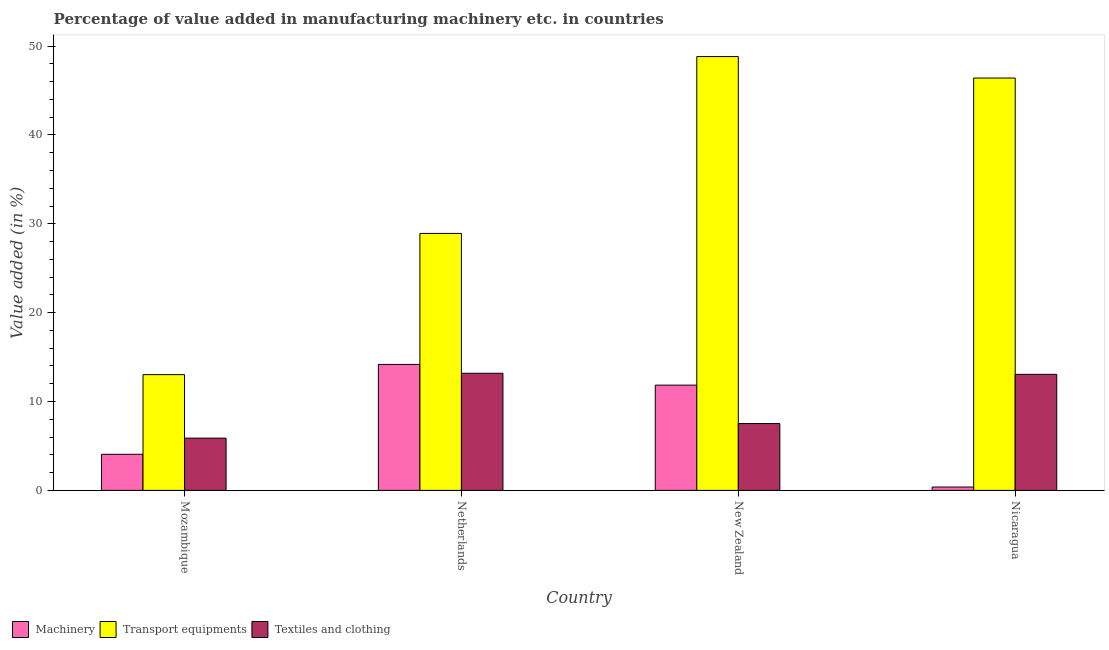Are the number of bars per tick equal to the number of legend labels?
Offer a terse response. Yes. What is the value added in manufacturing transport equipments in New Zealand?
Give a very brief answer. 48.82. Across all countries, what is the maximum value added in manufacturing machinery?
Your answer should be compact. 14.18. Across all countries, what is the minimum value added in manufacturing machinery?
Your response must be concise. 0.38. In which country was the value added in manufacturing textile and clothing minimum?
Keep it short and to the point. Mozambique. What is the total value added in manufacturing machinery in the graph?
Give a very brief answer. 30.46. What is the difference between the value added in manufacturing textile and clothing in Netherlands and that in Nicaragua?
Your answer should be very brief. 0.12. What is the difference between the value added in manufacturing textile and clothing in Nicaragua and the value added in manufacturing transport equipments in Mozambique?
Provide a short and direct response. 0.03. What is the average value added in manufacturing transport equipments per country?
Give a very brief answer. 34.29. What is the difference between the value added in manufacturing textile and clothing and value added in manufacturing machinery in Mozambique?
Provide a succinct answer. 1.82. What is the ratio of the value added in manufacturing transport equipments in Netherlands to that in New Zealand?
Provide a succinct answer. 0.59. Is the value added in manufacturing machinery in Netherlands less than that in New Zealand?
Give a very brief answer. No. What is the difference between the highest and the second highest value added in manufacturing machinery?
Offer a terse response. 2.33. What is the difference between the highest and the lowest value added in manufacturing machinery?
Make the answer very short. 13.8. Is the sum of the value added in manufacturing textile and clothing in Mozambique and Netherlands greater than the maximum value added in manufacturing machinery across all countries?
Provide a succinct answer. Yes. What does the 1st bar from the left in New Zealand represents?
Provide a succinct answer. Machinery. What does the 1st bar from the right in Netherlands represents?
Your answer should be compact. Textiles and clothing. How many bars are there?
Your answer should be very brief. 12. Are all the bars in the graph horizontal?
Your answer should be compact. No. How many countries are there in the graph?
Provide a succinct answer. 4. What is the difference between two consecutive major ticks on the Y-axis?
Offer a very short reply. 10. Are the values on the major ticks of Y-axis written in scientific E-notation?
Your response must be concise. No. Does the graph contain any zero values?
Provide a succinct answer. No. Does the graph contain grids?
Give a very brief answer. No. Where does the legend appear in the graph?
Provide a succinct answer. Bottom left. How many legend labels are there?
Offer a very short reply. 3. What is the title of the graph?
Provide a succinct answer. Percentage of value added in manufacturing machinery etc. in countries. Does "Renewable sources" appear as one of the legend labels in the graph?
Offer a very short reply. No. What is the label or title of the X-axis?
Ensure brevity in your answer.  Country. What is the label or title of the Y-axis?
Provide a succinct answer. Value added (in %). What is the Value added (in %) of Machinery in Mozambique?
Your answer should be compact. 4.06. What is the Value added (in %) of Transport equipments in Mozambique?
Provide a short and direct response. 13.03. What is the Value added (in %) of Textiles and clothing in Mozambique?
Your answer should be very brief. 5.88. What is the Value added (in %) of Machinery in Netherlands?
Your answer should be very brief. 14.18. What is the Value added (in %) in Transport equipments in Netherlands?
Your response must be concise. 28.92. What is the Value added (in %) of Textiles and clothing in Netherlands?
Make the answer very short. 13.18. What is the Value added (in %) in Machinery in New Zealand?
Your answer should be very brief. 11.84. What is the Value added (in %) of Transport equipments in New Zealand?
Make the answer very short. 48.82. What is the Value added (in %) in Textiles and clothing in New Zealand?
Give a very brief answer. 7.52. What is the Value added (in %) in Machinery in Nicaragua?
Your answer should be very brief. 0.38. What is the Value added (in %) of Transport equipments in Nicaragua?
Offer a very short reply. 46.4. What is the Value added (in %) in Textiles and clothing in Nicaragua?
Your answer should be compact. 13.06. Across all countries, what is the maximum Value added (in %) in Machinery?
Make the answer very short. 14.18. Across all countries, what is the maximum Value added (in %) of Transport equipments?
Keep it short and to the point. 48.82. Across all countries, what is the maximum Value added (in %) of Textiles and clothing?
Give a very brief answer. 13.18. Across all countries, what is the minimum Value added (in %) of Machinery?
Ensure brevity in your answer.  0.38. Across all countries, what is the minimum Value added (in %) in Transport equipments?
Give a very brief answer. 13.03. Across all countries, what is the minimum Value added (in %) in Textiles and clothing?
Offer a very short reply. 5.88. What is the total Value added (in %) in Machinery in the graph?
Offer a terse response. 30.46. What is the total Value added (in %) of Transport equipments in the graph?
Offer a very short reply. 137.17. What is the total Value added (in %) in Textiles and clothing in the graph?
Keep it short and to the point. 39.64. What is the difference between the Value added (in %) in Machinery in Mozambique and that in Netherlands?
Keep it short and to the point. -10.11. What is the difference between the Value added (in %) of Transport equipments in Mozambique and that in Netherlands?
Provide a short and direct response. -15.89. What is the difference between the Value added (in %) of Textiles and clothing in Mozambique and that in Netherlands?
Your response must be concise. -7.3. What is the difference between the Value added (in %) of Machinery in Mozambique and that in New Zealand?
Give a very brief answer. -7.78. What is the difference between the Value added (in %) in Transport equipments in Mozambique and that in New Zealand?
Offer a terse response. -35.79. What is the difference between the Value added (in %) of Textiles and clothing in Mozambique and that in New Zealand?
Ensure brevity in your answer.  -1.64. What is the difference between the Value added (in %) in Machinery in Mozambique and that in Nicaragua?
Your answer should be compact. 3.68. What is the difference between the Value added (in %) of Transport equipments in Mozambique and that in Nicaragua?
Keep it short and to the point. -33.38. What is the difference between the Value added (in %) in Textiles and clothing in Mozambique and that in Nicaragua?
Provide a succinct answer. -7.18. What is the difference between the Value added (in %) of Machinery in Netherlands and that in New Zealand?
Ensure brevity in your answer.  2.33. What is the difference between the Value added (in %) of Transport equipments in Netherlands and that in New Zealand?
Offer a terse response. -19.9. What is the difference between the Value added (in %) in Textiles and clothing in Netherlands and that in New Zealand?
Keep it short and to the point. 5.66. What is the difference between the Value added (in %) in Machinery in Netherlands and that in Nicaragua?
Offer a terse response. 13.8. What is the difference between the Value added (in %) in Transport equipments in Netherlands and that in Nicaragua?
Ensure brevity in your answer.  -17.49. What is the difference between the Value added (in %) in Textiles and clothing in Netherlands and that in Nicaragua?
Your answer should be very brief. 0.12. What is the difference between the Value added (in %) in Machinery in New Zealand and that in Nicaragua?
Give a very brief answer. 11.47. What is the difference between the Value added (in %) in Transport equipments in New Zealand and that in Nicaragua?
Your response must be concise. 2.41. What is the difference between the Value added (in %) in Textiles and clothing in New Zealand and that in Nicaragua?
Your answer should be compact. -5.54. What is the difference between the Value added (in %) in Machinery in Mozambique and the Value added (in %) in Transport equipments in Netherlands?
Give a very brief answer. -24.86. What is the difference between the Value added (in %) of Machinery in Mozambique and the Value added (in %) of Textiles and clothing in Netherlands?
Provide a succinct answer. -9.12. What is the difference between the Value added (in %) of Transport equipments in Mozambique and the Value added (in %) of Textiles and clothing in Netherlands?
Your response must be concise. -0.15. What is the difference between the Value added (in %) of Machinery in Mozambique and the Value added (in %) of Transport equipments in New Zealand?
Give a very brief answer. -44.76. What is the difference between the Value added (in %) of Machinery in Mozambique and the Value added (in %) of Textiles and clothing in New Zealand?
Keep it short and to the point. -3.46. What is the difference between the Value added (in %) in Transport equipments in Mozambique and the Value added (in %) in Textiles and clothing in New Zealand?
Give a very brief answer. 5.51. What is the difference between the Value added (in %) in Machinery in Mozambique and the Value added (in %) in Transport equipments in Nicaragua?
Ensure brevity in your answer.  -42.34. What is the difference between the Value added (in %) of Machinery in Mozambique and the Value added (in %) of Textiles and clothing in Nicaragua?
Give a very brief answer. -9. What is the difference between the Value added (in %) in Transport equipments in Mozambique and the Value added (in %) in Textiles and clothing in Nicaragua?
Provide a succinct answer. -0.03. What is the difference between the Value added (in %) of Machinery in Netherlands and the Value added (in %) of Transport equipments in New Zealand?
Offer a very short reply. -34.64. What is the difference between the Value added (in %) of Machinery in Netherlands and the Value added (in %) of Textiles and clothing in New Zealand?
Keep it short and to the point. 6.66. What is the difference between the Value added (in %) of Transport equipments in Netherlands and the Value added (in %) of Textiles and clothing in New Zealand?
Offer a terse response. 21.4. What is the difference between the Value added (in %) in Machinery in Netherlands and the Value added (in %) in Transport equipments in Nicaragua?
Make the answer very short. -32.23. What is the difference between the Value added (in %) of Machinery in Netherlands and the Value added (in %) of Textiles and clothing in Nicaragua?
Keep it short and to the point. 1.12. What is the difference between the Value added (in %) in Transport equipments in Netherlands and the Value added (in %) in Textiles and clothing in Nicaragua?
Offer a terse response. 15.86. What is the difference between the Value added (in %) in Machinery in New Zealand and the Value added (in %) in Transport equipments in Nicaragua?
Provide a succinct answer. -34.56. What is the difference between the Value added (in %) of Machinery in New Zealand and the Value added (in %) of Textiles and clothing in Nicaragua?
Give a very brief answer. -1.22. What is the difference between the Value added (in %) of Transport equipments in New Zealand and the Value added (in %) of Textiles and clothing in Nicaragua?
Offer a very short reply. 35.76. What is the average Value added (in %) in Machinery per country?
Provide a succinct answer. 7.62. What is the average Value added (in %) of Transport equipments per country?
Your answer should be very brief. 34.29. What is the average Value added (in %) of Textiles and clothing per country?
Your answer should be compact. 9.91. What is the difference between the Value added (in %) in Machinery and Value added (in %) in Transport equipments in Mozambique?
Offer a terse response. -8.97. What is the difference between the Value added (in %) of Machinery and Value added (in %) of Textiles and clothing in Mozambique?
Keep it short and to the point. -1.82. What is the difference between the Value added (in %) of Transport equipments and Value added (in %) of Textiles and clothing in Mozambique?
Your response must be concise. 7.14. What is the difference between the Value added (in %) in Machinery and Value added (in %) in Transport equipments in Netherlands?
Your response must be concise. -14.74. What is the difference between the Value added (in %) in Machinery and Value added (in %) in Textiles and clothing in Netherlands?
Your answer should be compact. 1. What is the difference between the Value added (in %) in Transport equipments and Value added (in %) in Textiles and clothing in Netherlands?
Make the answer very short. 15.74. What is the difference between the Value added (in %) of Machinery and Value added (in %) of Transport equipments in New Zealand?
Make the answer very short. -36.97. What is the difference between the Value added (in %) in Machinery and Value added (in %) in Textiles and clothing in New Zealand?
Ensure brevity in your answer.  4.32. What is the difference between the Value added (in %) in Transport equipments and Value added (in %) in Textiles and clothing in New Zealand?
Offer a very short reply. 41.3. What is the difference between the Value added (in %) in Machinery and Value added (in %) in Transport equipments in Nicaragua?
Offer a terse response. -46.03. What is the difference between the Value added (in %) in Machinery and Value added (in %) in Textiles and clothing in Nicaragua?
Make the answer very short. -12.68. What is the difference between the Value added (in %) of Transport equipments and Value added (in %) of Textiles and clothing in Nicaragua?
Give a very brief answer. 33.35. What is the ratio of the Value added (in %) of Machinery in Mozambique to that in Netherlands?
Your answer should be very brief. 0.29. What is the ratio of the Value added (in %) in Transport equipments in Mozambique to that in Netherlands?
Provide a short and direct response. 0.45. What is the ratio of the Value added (in %) of Textiles and clothing in Mozambique to that in Netherlands?
Offer a terse response. 0.45. What is the ratio of the Value added (in %) in Machinery in Mozambique to that in New Zealand?
Offer a terse response. 0.34. What is the ratio of the Value added (in %) of Transport equipments in Mozambique to that in New Zealand?
Provide a succinct answer. 0.27. What is the ratio of the Value added (in %) in Textiles and clothing in Mozambique to that in New Zealand?
Offer a terse response. 0.78. What is the ratio of the Value added (in %) in Machinery in Mozambique to that in Nicaragua?
Keep it short and to the point. 10.72. What is the ratio of the Value added (in %) in Transport equipments in Mozambique to that in Nicaragua?
Your response must be concise. 0.28. What is the ratio of the Value added (in %) of Textiles and clothing in Mozambique to that in Nicaragua?
Your answer should be compact. 0.45. What is the ratio of the Value added (in %) of Machinery in Netherlands to that in New Zealand?
Make the answer very short. 1.2. What is the ratio of the Value added (in %) of Transport equipments in Netherlands to that in New Zealand?
Your response must be concise. 0.59. What is the ratio of the Value added (in %) in Textiles and clothing in Netherlands to that in New Zealand?
Keep it short and to the point. 1.75. What is the ratio of the Value added (in %) in Machinery in Netherlands to that in Nicaragua?
Your answer should be very brief. 37.4. What is the ratio of the Value added (in %) in Transport equipments in Netherlands to that in Nicaragua?
Provide a succinct answer. 0.62. What is the ratio of the Value added (in %) of Textiles and clothing in Netherlands to that in Nicaragua?
Keep it short and to the point. 1.01. What is the ratio of the Value added (in %) of Machinery in New Zealand to that in Nicaragua?
Give a very brief answer. 31.25. What is the ratio of the Value added (in %) of Transport equipments in New Zealand to that in Nicaragua?
Offer a terse response. 1.05. What is the ratio of the Value added (in %) in Textiles and clothing in New Zealand to that in Nicaragua?
Offer a very short reply. 0.58. What is the difference between the highest and the second highest Value added (in %) in Machinery?
Give a very brief answer. 2.33. What is the difference between the highest and the second highest Value added (in %) in Transport equipments?
Your response must be concise. 2.41. What is the difference between the highest and the second highest Value added (in %) of Textiles and clothing?
Provide a succinct answer. 0.12. What is the difference between the highest and the lowest Value added (in %) in Machinery?
Make the answer very short. 13.8. What is the difference between the highest and the lowest Value added (in %) of Transport equipments?
Provide a succinct answer. 35.79. What is the difference between the highest and the lowest Value added (in %) in Textiles and clothing?
Ensure brevity in your answer.  7.3. 